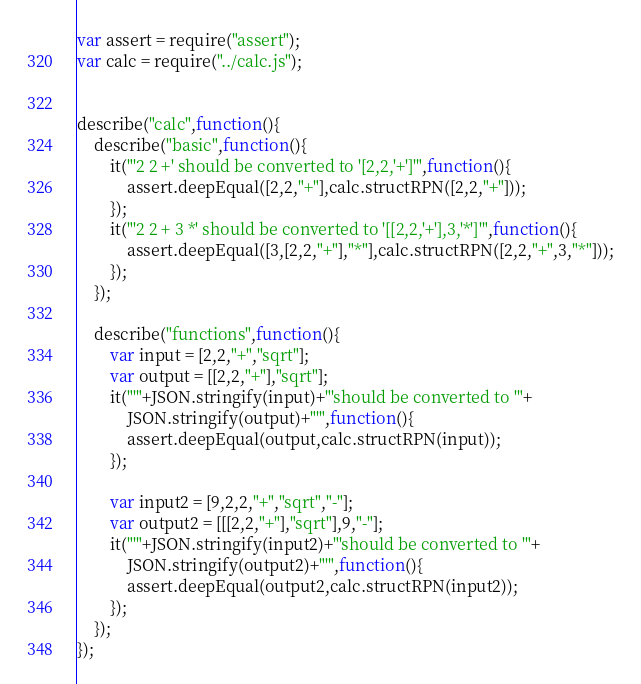<code> <loc_0><loc_0><loc_500><loc_500><_JavaScript_>var assert = require("assert");
var calc = require("../calc.js");


describe("calc",function(){
    describe("basic",function(){
        it("'2 2 +' should be converted to '[2,2,'+']'",function(){
            assert.deepEqual([2,2,"+"],calc.structRPN([2,2,"+"]));
        });
        it("'2 2 + 3 *' should be converted to '[[2,2,'+'],3,'*']'",function(){
            assert.deepEqual([3,[2,2,"+"],"*"],calc.structRPN([2,2,"+",3,"*"]));
        });
    });

    describe("functions",function(){
        var input = [2,2,"+","sqrt"];
        var output = [[2,2,"+"],"sqrt"];
        it("'"+JSON.stringify(input)+"'should be converted to '"+
            JSON.stringify(output)+"'",function(){
            assert.deepEqual(output,calc.structRPN(input));
        });

        var input2 = [9,2,2,"+","sqrt","-"];
        var output2 = [[[2,2,"+"],"sqrt"],9,"-"];
        it("'"+JSON.stringify(input2)+"'should be converted to '"+
            JSON.stringify(output2)+"'",function(){
            assert.deepEqual(output2,calc.structRPN(input2));
        });
    });
});

</code> 